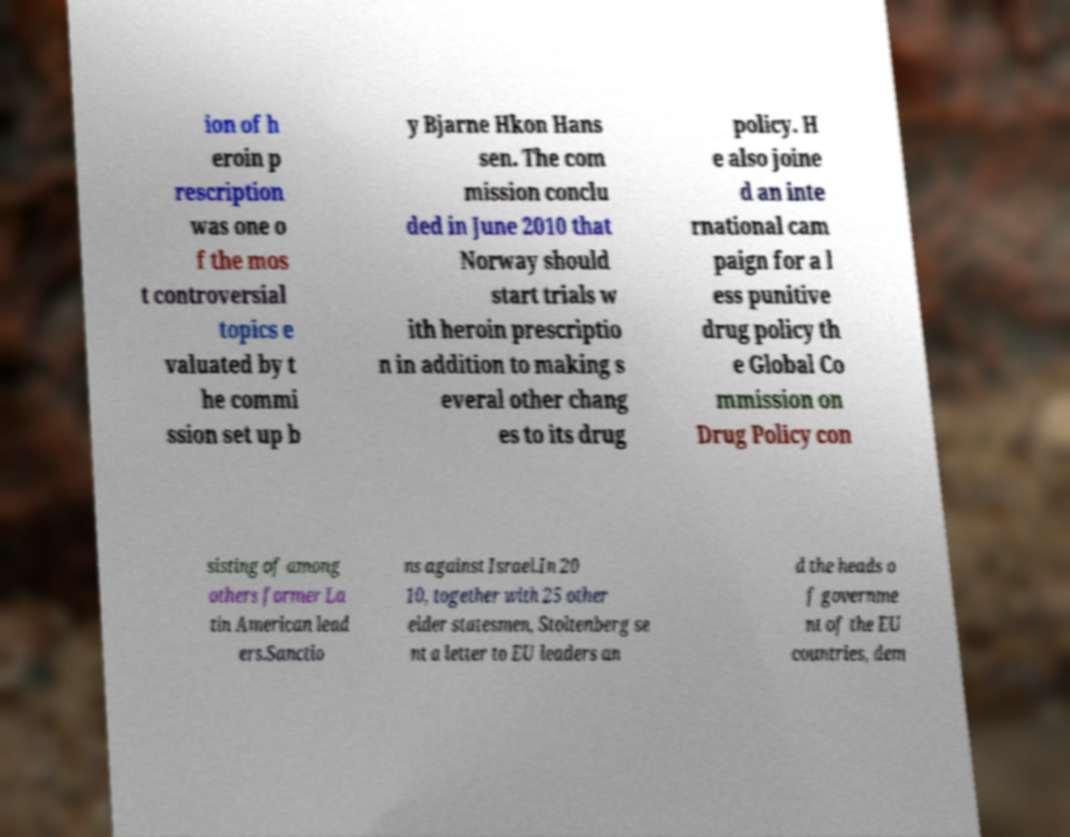I need the written content from this picture converted into text. Can you do that? ion of h eroin p rescription was one o f the mos t controversial topics e valuated by t he commi ssion set up b y Bjarne Hkon Hans sen. The com mission conclu ded in June 2010 that Norway should start trials w ith heroin prescriptio n in addition to making s everal other chang es to its drug policy. H e also joine d an inte rnational cam paign for a l ess punitive drug policy th e Global Co mmission on Drug Policy con sisting of among others former La tin American lead ers.Sanctio ns against Israel.In 20 10, together with 25 other elder statesmen, Stoltenberg se nt a letter to EU leaders an d the heads o f governme nt of the EU countries, dem 